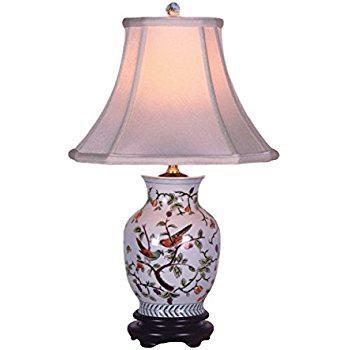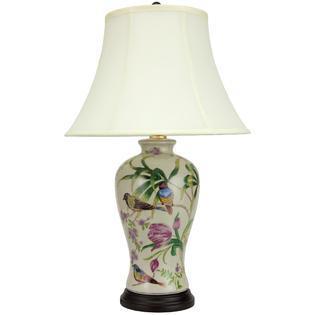The first image is the image on the left, the second image is the image on the right. Considering the images on both sides, is "The ceramic base of the lamp on the right has a fuller top and tapers toward the bottom, and the base of the lamp on the left is decorated with a bird and flowers and has a dark footed bottom." valid? Answer yes or no. Yes. 